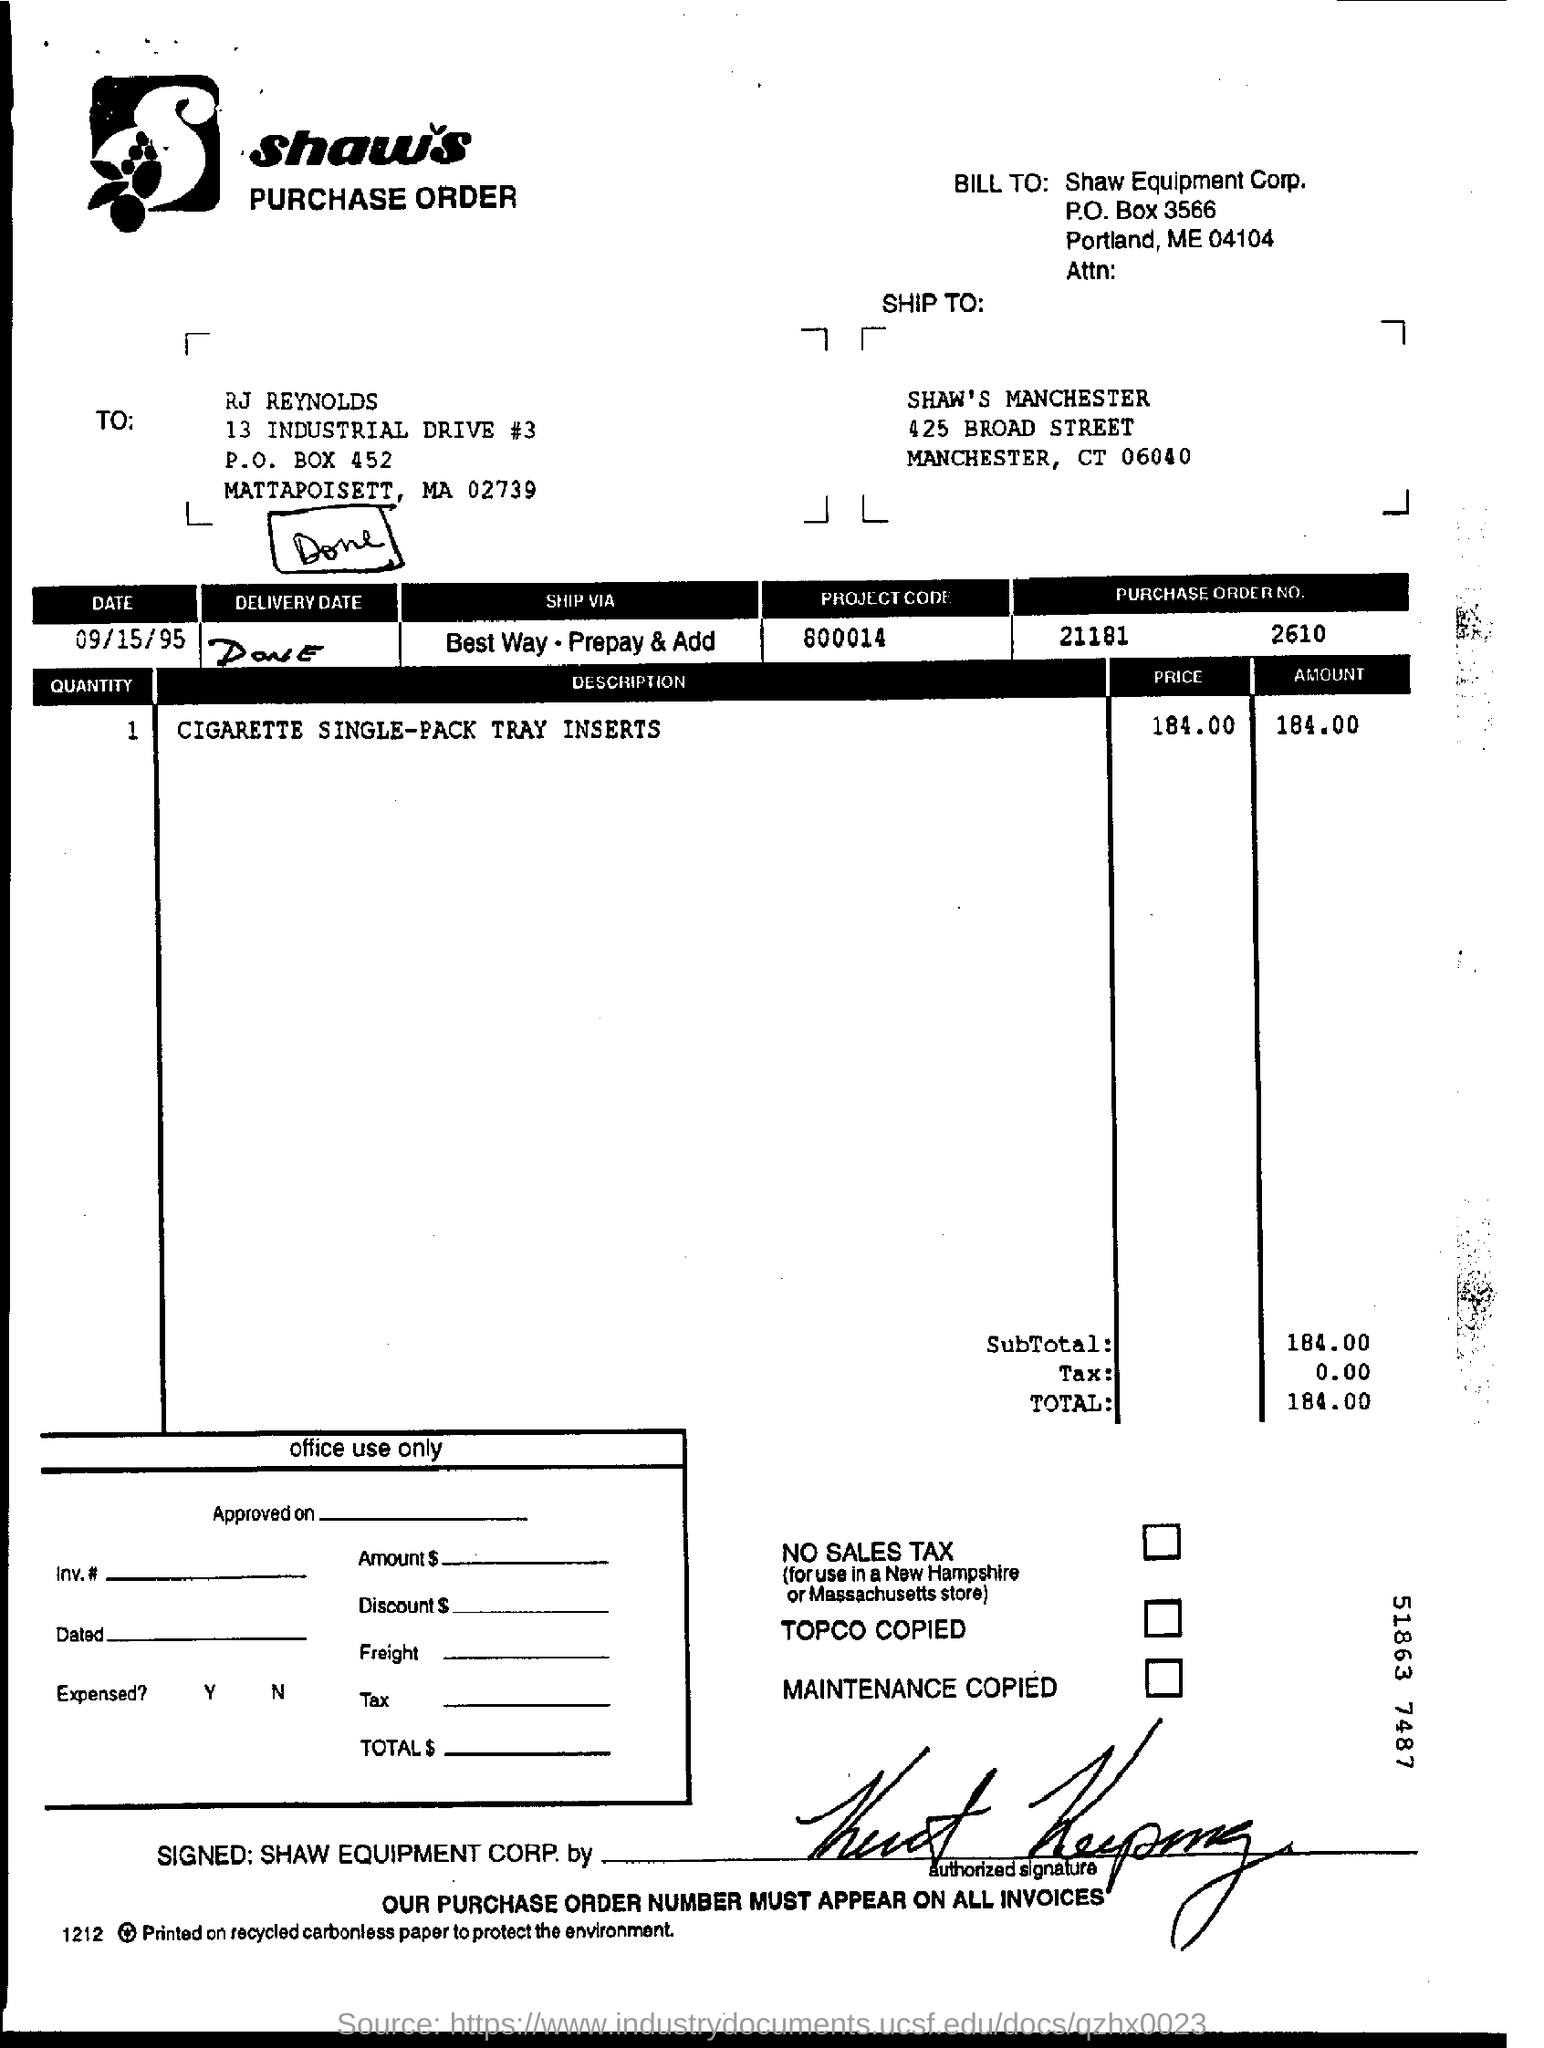What is the date mentioned ?
Your response must be concise. 09/15/95. What is the project code ?
Ensure brevity in your answer.  800014. What is the purchase order no
Your response must be concise. 21181    2610. 